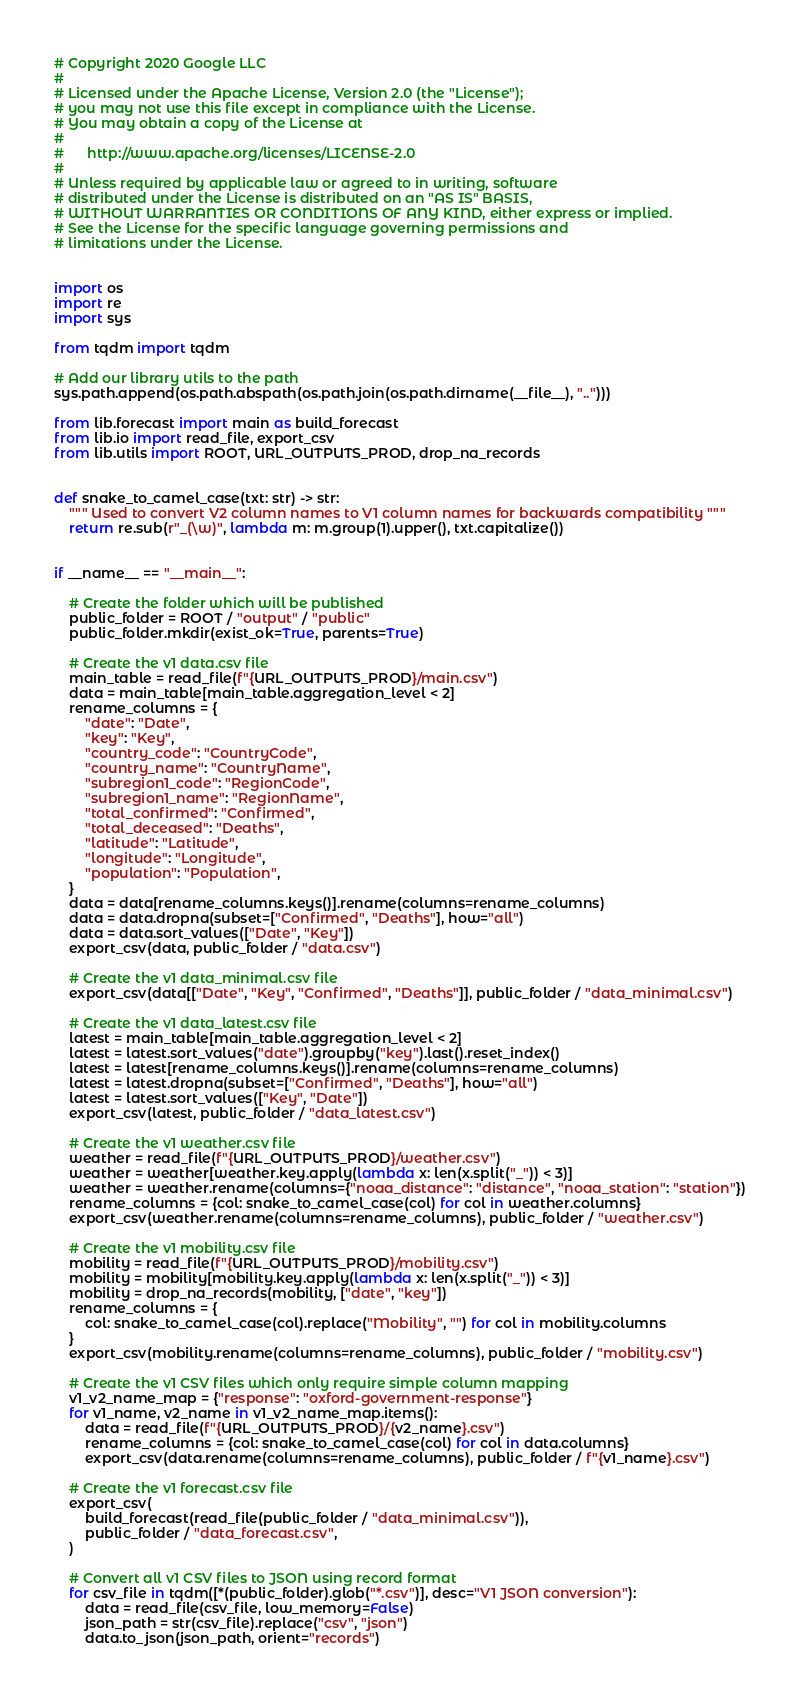<code> <loc_0><loc_0><loc_500><loc_500><_Python_># Copyright 2020 Google LLC
#
# Licensed under the Apache License, Version 2.0 (the "License");
# you may not use this file except in compliance with the License.
# You may obtain a copy of the License at
#
#      http://www.apache.org/licenses/LICENSE-2.0
#
# Unless required by applicable law or agreed to in writing, software
# distributed under the License is distributed on an "AS IS" BASIS,
# WITHOUT WARRANTIES OR CONDITIONS OF ANY KIND, either express or implied.
# See the License for the specific language governing permissions and
# limitations under the License.


import os
import re
import sys

from tqdm import tqdm

# Add our library utils to the path
sys.path.append(os.path.abspath(os.path.join(os.path.dirname(__file__), "..")))

from lib.forecast import main as build_forecast
from lib.io import read_file, export_csv
from lib.utils import ROOT, URL_OUTPUTS_PROD, drop_na_records


def snake_to_camel_case(txt: str) -> str:
    """ Used to convert V2 column names to V1 column names for backwards compatibility """
    return re.sub(r"_(\w)", lambda m: m.group(1).upper(), txt.capitalize())


if __name__ == "__main__":

    # Create the folder which will be published
    public_folder = ROOT / "output" / "public"
    public_folder.mkdir(exist_ok=True, parents=True)

    # Create the v1 data.csv file
    main_table = read_file(f"{URL_OUTPUTS_PROD}/main.csv")
    data = main_table[main_table.aggregation_level < 2]
    rename_columns = {
        "date": "Date",
        "key": "Key",
        "country_code": "CountryCode",
        "country_name": "CountryName",
        "subregion1_code": "RegionCode",
        "subregion1_name": "RegionName",
        "total_confirmed": "Confirmed",
        "total_deceased": "Deaths",
        "latitude": "Latitude",
        "longitude": "Longitude",
        "population": "Population",
    }
    data = data[rename_columns.keys()].rename(columns=rename_columns)
    data = data.dropna(subset=["Confirmed", "Deaths"], how="all")
    data = data.sort_values(["Date", "Key"])
    export_csv(data, public_folder / "data.csv")

    # Create the v1 data_minimal.csv file
    export_csv(data[["Date", "Key", "Confirmed", "Deaths"]], public_folder / "data_minimal.csv")

    # Create the v1 data_latest.csv file
    latest = main_table[main_table.aggregation_level < 2]
    latest = latest.sort_values("date").groupby("key").last().reset_index()
    latest = latest[rename_columns.keys()].rename(columns=rename_columns)
    latest = latest.dropna(subset=["Confirmed", "Deaths"], how="all")
    latest = latest.sort_values(["Key", "Date"])
    export_csv(latest, public_folder / "data_latest.csv")

    # Create the v1 weather.csv file
    weather = read_file(f"{URL_OUTPUTS_PROD}/weather.csv")
    weather = weather[weather.key.apply(lambda x: len(x.split("_")) < 3)]
    weather = weather.rename(columns={"noaa_distance": "distance", "noaa_station": "station"})
    rename_columns = {col: snake_to_camel_case(col) for col in weather.columns}
    export_csv(weather.rename(columns=rename_columns), public_folder / "weather.csv")

    # Create the v1 mobility.csv file
    mobility = read_file(f"{URL_OUTPUTS_PROD}/mobility.csv")
    mobility = mobility[mobility.key.apply(lambda x: len(x.split("_")) < 3)]
    mobility = drop_na_records(mobility, ["date", "key"])
    rename_columns = {
        col: snake_to_camel_case(col).replace("Mobility", "") for col in mobility.columns
    }
    export_csv(mobility.rename(columns=rename_columns), public_folder / "mobility.csv")

    # Create the v1 CSV files which only require simple column mapping
    v1_v2_name_map = {"response": "oxford-government-response"}
    for v1_name, v2_name in v1_v2_name_map.items():
        data = read_file(f"{URL_OUTPUTS_PROD}/{v2_name}.csv")
        rename_columns = {col: snake_to_camel_case(col) for col in data.columns}
        export_csv(data.rename(columns=rename_columns), public_folder / f"{v1_name}.csv")

    # Create the v1 forecast.csv file
    export_csv(
        build_forecast(read_file(public_folder / "data_minimal.csv")),
        public_folder / "data_forecast.csv",
    )

    # Convert all v1 CSV files to JSON using record format
    for csv_file in tqdm([*(public_folder).glob("*.csv")], desc="V1 JSON conversion"):
        data = read_file(csv_file, low_memory=False)
        json_path = str(csv_file).replace("csv", "json")
        data.to_json(json_path, orient="records")
</code> 